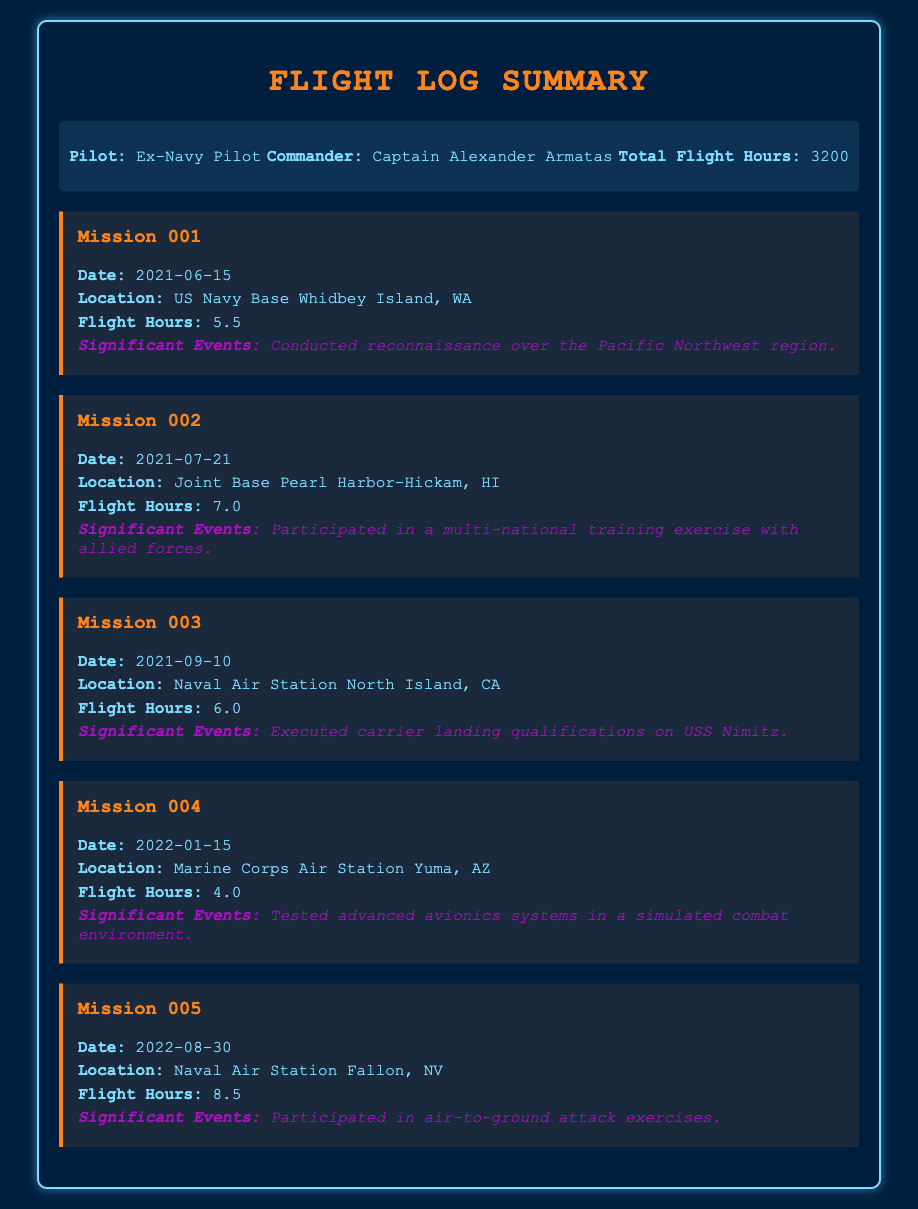What is the total flight hours? The total flight hours is listed in the summary section of the document.
Answer: 3200 What is the date of Mission 003? The date of Mission 003 is found under that specific mission's details.
Answer: 2021-09-10 Where was Mission 002 conducted? The location of Mission 002 is specified in the details of that mission.
Answer: Joint Base Pearl Harbor-Hickam, HI What significant event occurred during Mission 004? The significant event for Mission 004 is mentioned in the event section of that mission.
Answer: Tested advanced avionics systems in a simulated combat environment How many flight hours were logged during Mission 005? The flight hours for Mission 005 is directly noted in the details of the mission.
Answer: 8.5 